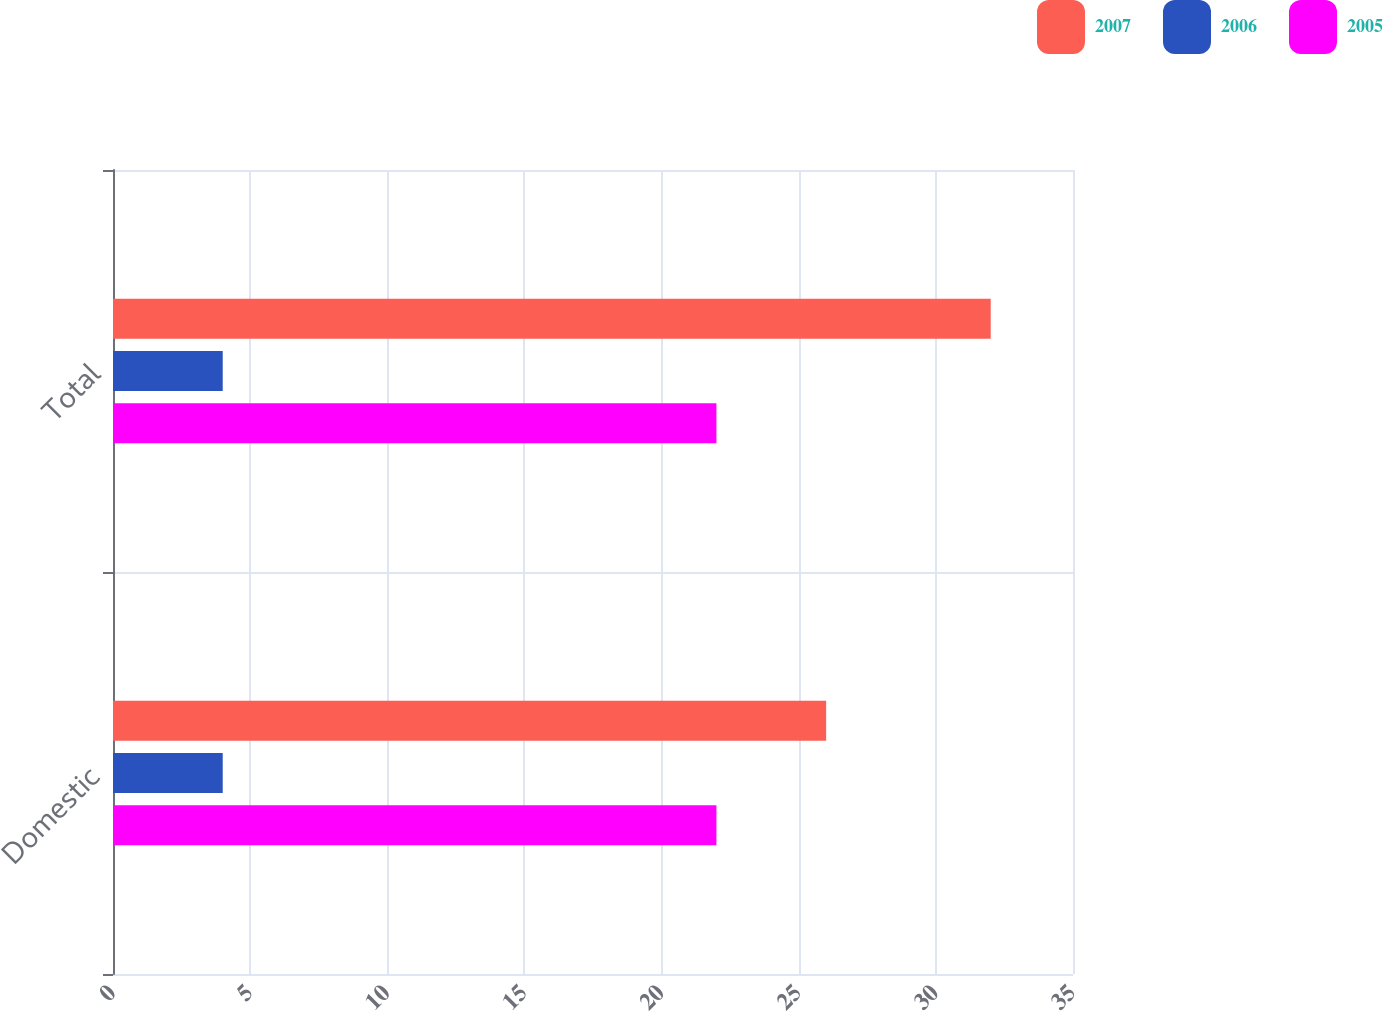Convert chart to OTSL. <chart><loc_0><loc_0><loc_500><loc_500><stacked_bar_chart><ecel><fcel>Domestic<fcel>Total<nl><fcel>2007<fcel>26<fcel>32<nl><fcel>2006<fcel>4<fcel>4<nl><fcel>2005<fcel>22<fcel>22<nl></chart> 